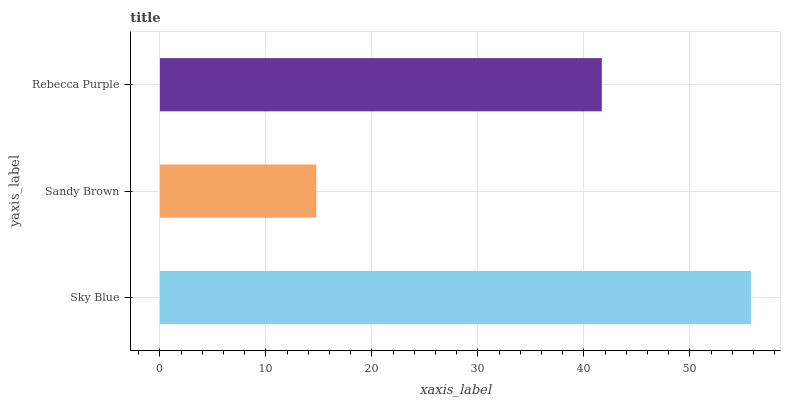Is Sandy Brown the minimum?
Answer yes or no. Yes. Is Sky Blue the maximum?
Answer yes or no. Yes. Is Rebecca Purple the minimum?
Answer yes or no. No. Is Rebecca Purple the maximum?
Answer yes or no. No. Is Rebecca Purple greater than Sandy Brown?
Answer yes or no. Yes. Is Sandy Brown less than Rebecca Purple?
Answer yes or no. Yes. Is Sandy Brown greater than Rebecca Purple?
Answer yes or no. No. Is Rebecca Purple less than Sandy Brown?
Answer yes or no. No. Is Rebecca Purple the high median?
Answer yes or no. Yes. Is Rebecca Purple the low median?
Answer yes or no. Yes. Is Sky Blue the high median?
Answer yes or no. No. Is Sky Blue the low median?
Answer yes or no. No. 